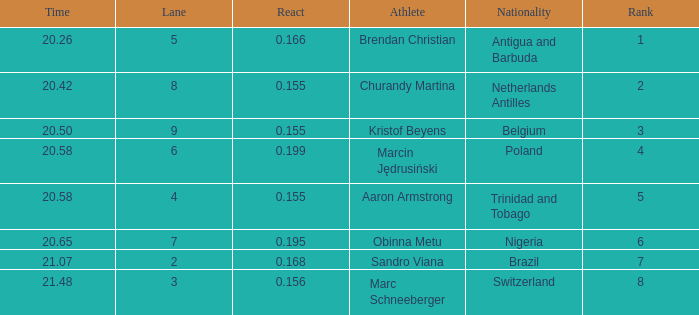Which Lane has a Time larger than 20.5, and a Nationality of trinidad and tobago? 4.0. 